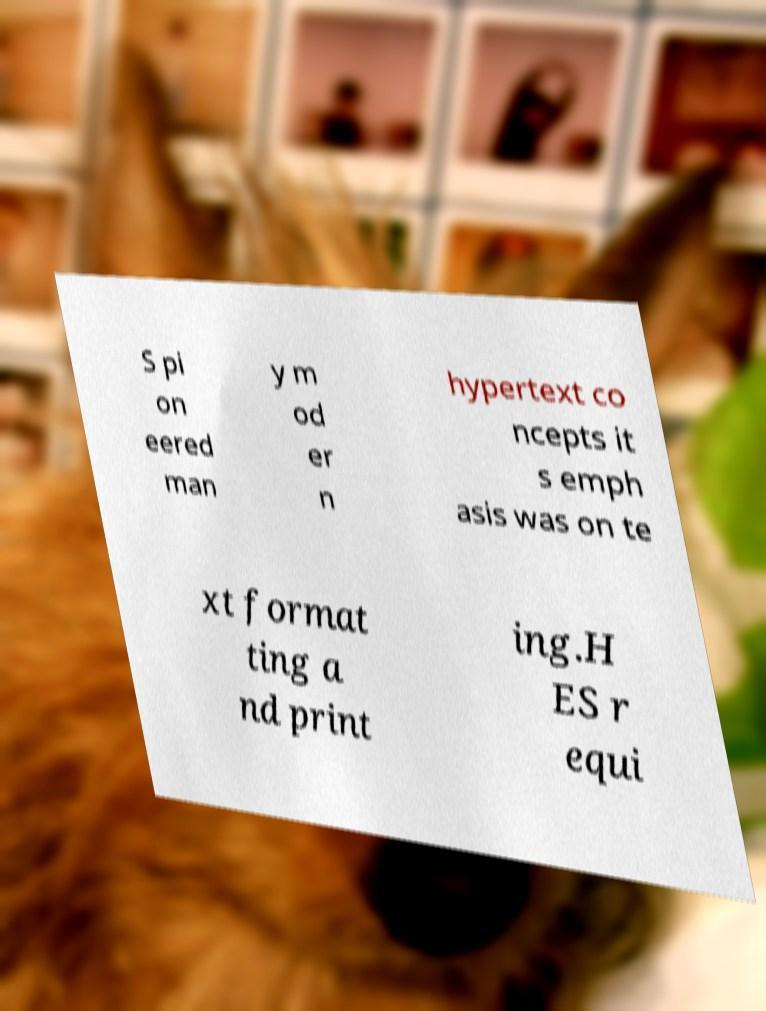Can you accurately transcribe the text from the provided image for me? S pi on eered man y m od er n hypertext co ncepts it s emph asis was on te xt format ting a nd print ing.H ES r equi 